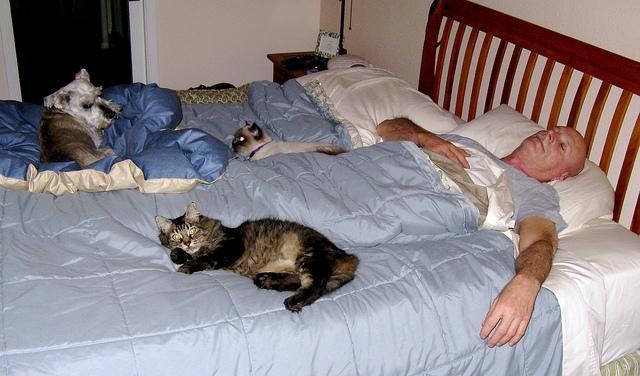How many different species of animal are relaxing in bed?
Give a very brief answer. 2. How many cats are visible?
Give a very brief answer. 2. How many dogs are in the picture?
Give a very brief answer. 1. How many zebras are there?
Give a very brief answer. 0. 